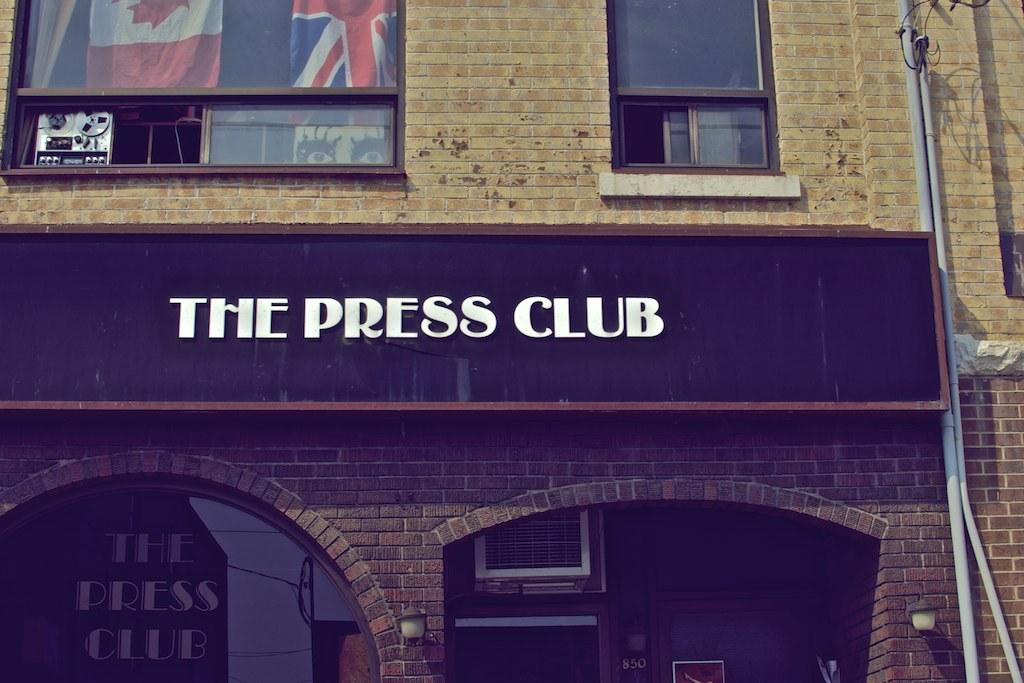What is the primary object in the image? There is a name board in the image. What other items can be seen in the image? There are flags, windows, lamps, a wall, and some unspecified objects in the image. Can you describe the flags in the image? Unfortunately, the facts provided do not specify the details of the flags. What type of lighting is present in the image? There are lamps in the image, which suggests some form of lighting. What type of bird can be seen perched on the low branch in the image? There is no bird or low branch present in the image. What type of bait is being used to catch fish in the image? There is no fishing or bait present in the image. 